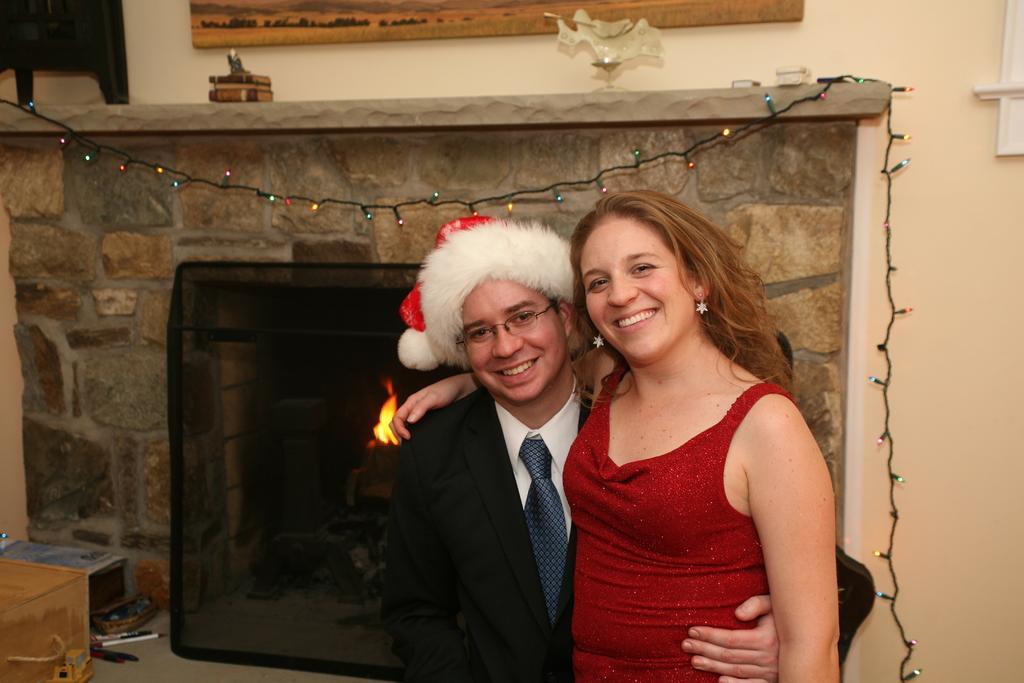Can you describe this image briefly? There is a man wearing a Santa cap and a woman, both are standing in the foreground area of the image, there is a building, fire and colorful lights in the background. 